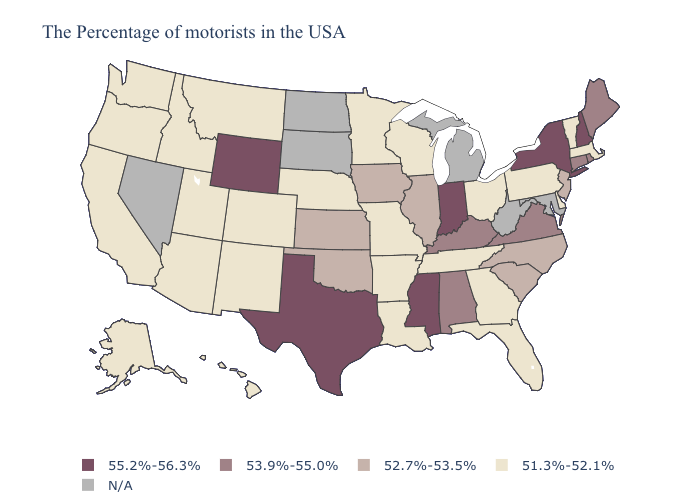Name the states that have a value in the range 55.2%-56.3%?
Write a very short answer. New Hampshire, New York, Indiana, Mississippi, Texas, Wyoming. Name the states that have a value in the range 53.9%-55.0%?
Answer briefly. Maine, Rhode Island, Connecticut, Virginia, Kentucky, Alabama. What is the highest value in states that border Virginia?
Short answer required. 53.9%-55.0%. What is the lowest value in the USA?
Short answer required. 51.3%-52.1%. What is the value of Texas?
Give a very brief answer. 55.2%-56.3%. Among the states that border Maryland , does Delaware have the lowest value?
Answer briefly. Yes. What is the lowest value in the USA?
Keep it brief. 51.3%-52.1%. Name the states that have a value in the range 51.3%-52.1%?
Be succinct. Massachusetts, Vermont, Delaware, Pennsylvania, Ohio, Florida, Georgia, Tennessee, Wisconsin, Louisiana, Missouri, Arkansas, Minnesota, Nebraska, Colorado, New Mexico, Utah, Montana, Arizona, Idaho, California, Washington, Oregon, Alaska, Hawaii. Which states have the lowest value in the USA?
Keep it brief. Massachusetts, Vermont, Delaware, Pennsylvania, Ohio, Florida, Georgia, Tennessee, Wisconsin, Louisiana, Missouri, Arkansas, Minnesota, Nebraska, Colorado, New Mexico, Utah, Montana, Arizona, Idaho, California, Washington, Oregon, Alaska, Hawaii. What is the value of West Virginia?
Short answer required. N/A. What is the lowest value in states that border Illinois?
Quick response, please. 51.3%-52.1%. Does Wisconsin have the highest value in the MidWest?
Concise answer only. No. Name the states that have a value in the range 51.3%-52.1%?
Give a very brief answer. Massachusetts, Vermont, Delaware, Pennsylvania, Ohio, Florida, Georgia, Tennessee, Wisconsin, Louisiana, Missouri, Arkansas, Minnesota, Nebraska, Colorado, New Mexico, Utah, Montana, Arizona, Idaho, California, Washington, Oregon, Alaska, Hawaii. Name the states that have a value in the range 53.9%-55.0%?
Be succinct. Maine, Rhode Island, Connecticut, Virginia, Kentucky, Alabama. Name the states that have a value in the range 51.3%-52.1%?
Answer briefly. Massachusetts, Vermont, Delaware, Pennsylvania, Ohio, Florida, Georgia, Tennessee, Wisconsin, Louisiana, Missouri, Arkansas, Minnesota, Nebraska, Colorado, New Mexico, Utah, Montana, Arizona, Idaho, California, Washington, Oregon, Alaska, Hawaii. 